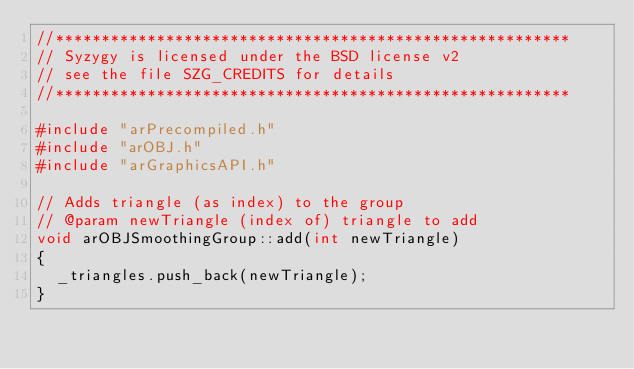Convert code to text. <code><loc_0><loc_0><loc_500><loc_500><_C++_>//********************************************************
// Syzygy is licensed under the BSD license v2
// see the file SZG_CREDITS for details
//********************************************************

#include "arPrecompiled.h"
#include "arOBJ.h"
#include "arGraphicsAPI.h"

// Adds triangle (as index) to the group
// @param newTriangle (index of) triangle to add
void arOBJSmoothingGroup::add(int newTriangle)
{
  _triangles.push_back(newTriangle);
}
</code> 